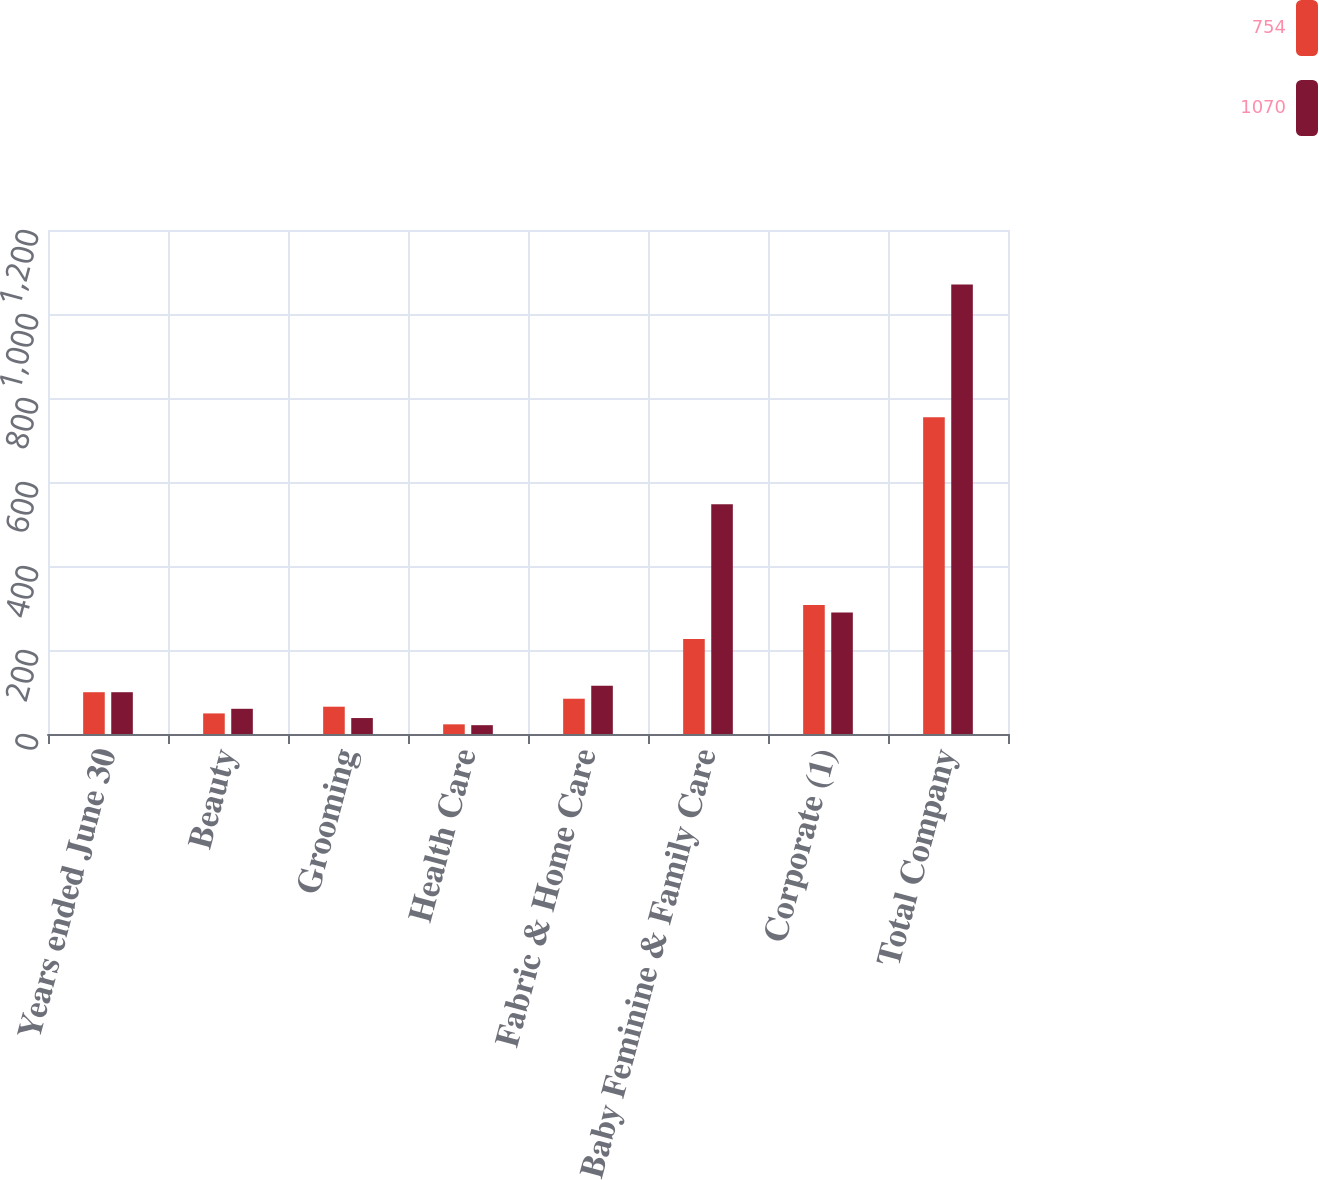Convert chart. <chart><loc_0><loc_0><loc_500><loc_500><stacked_bar_chart><ecel><fcel>Years ended June 30<fcel>Beauty<fcel>Grooming<fcel>Health Care<fcel>Fabric & Home Care<fcel>Baby Feminine & Family Care<fcel>Corporate (1)<fcel>Total Company<nl><fcel>754<fcel>99.5<fcel>49<fcel>65<fcel>23<fcel>84<fcel>226<fcel>307<fcel>754<nl><fcel>1070<fcel>99.5<fcel>60<fcel>38<fcel>21<fcel>115<fcel>547<fcel>289<fcel>1070<nl></chart> 